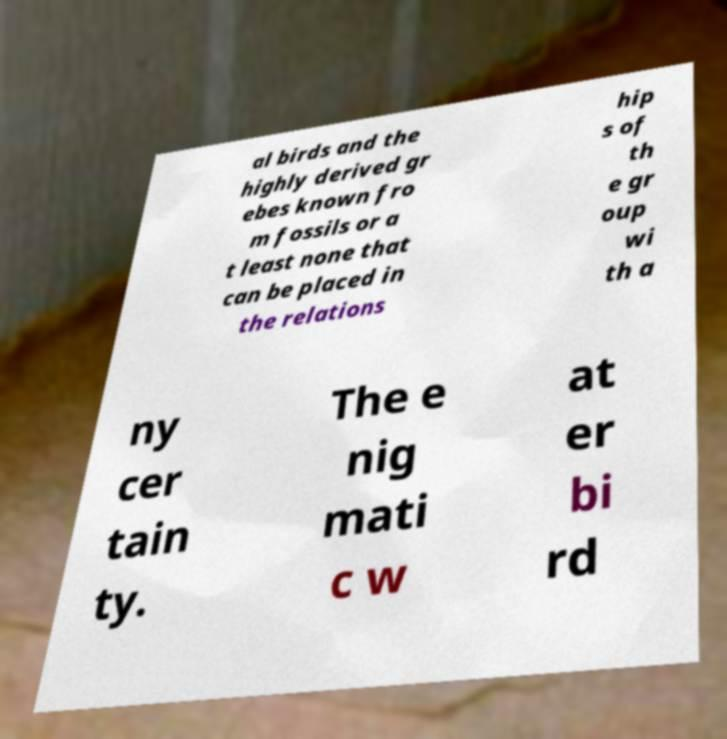Please identify and transcribe the text found in this image. al birds and the highly derived gr ebes known fro m fossils or a t least none that can be placed in the relations hip s of th e gr oup wi th a ny cer tain ty. The e nig mati c w at er bi rd 